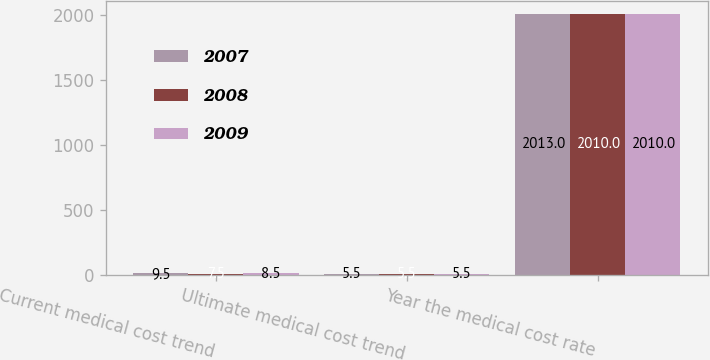Convert chart. <chart><loc_0><loc_0><loc_500><loc_500><stacked_bar_chart><ecel><fcel>Current medical cost trend<fcel>Ultimate medical cost trend<fcel>Year the medical cost rate<nl><fcel>2007<fcel>9.5<fcel>5.5<fcel>2013<nl><fcel>2008<fcel>7.5<fcel>5.5<fcel>2010<nl><fcel>2009<fcel>8.5<fcel>5.5<fcel>2010<nl></chart> 